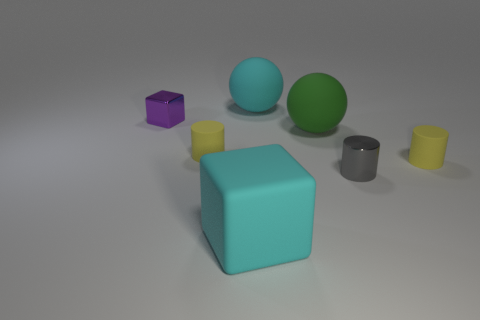Subtract all red blocks. How many yellow cylinders are left? 2 Subtract all tiny matte cylinders. How many cylinders are left? 1 Add 1 tiny rubber objects. How many objects exist? 8 Subtract all blocks. How many objects are left? 5 Subtract 0 gray balls. How many objects are left? 7 Subtract all yellow spheres. Subtract all purple cylinders. How many spheres are left? 2 Subtract all green metallic objects. Subtract all large green rubber spheres. How many objects are left? 6 Add 2 big cyan rubber balls. How many big cyan rubber balls are left? 3 Add 5 gray metal things. How many gray metal things exist? 6 